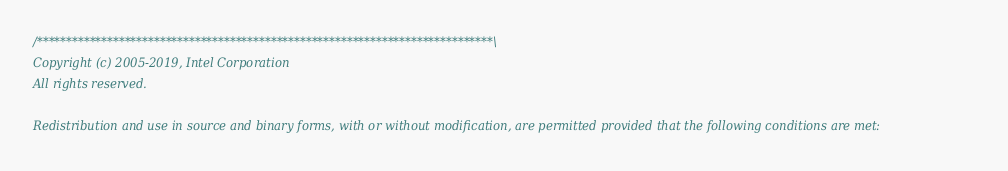<code> <loc_0><loc_0><loc_500><loc_500><_C++_>/******************************************************************************\
Copyright (c) 2005-2019, Intel Corporation
All rights reserved.

Redistribution and use in source and binary forms, with or without modification, are permitted provided that the following conditions are met:
</code> 